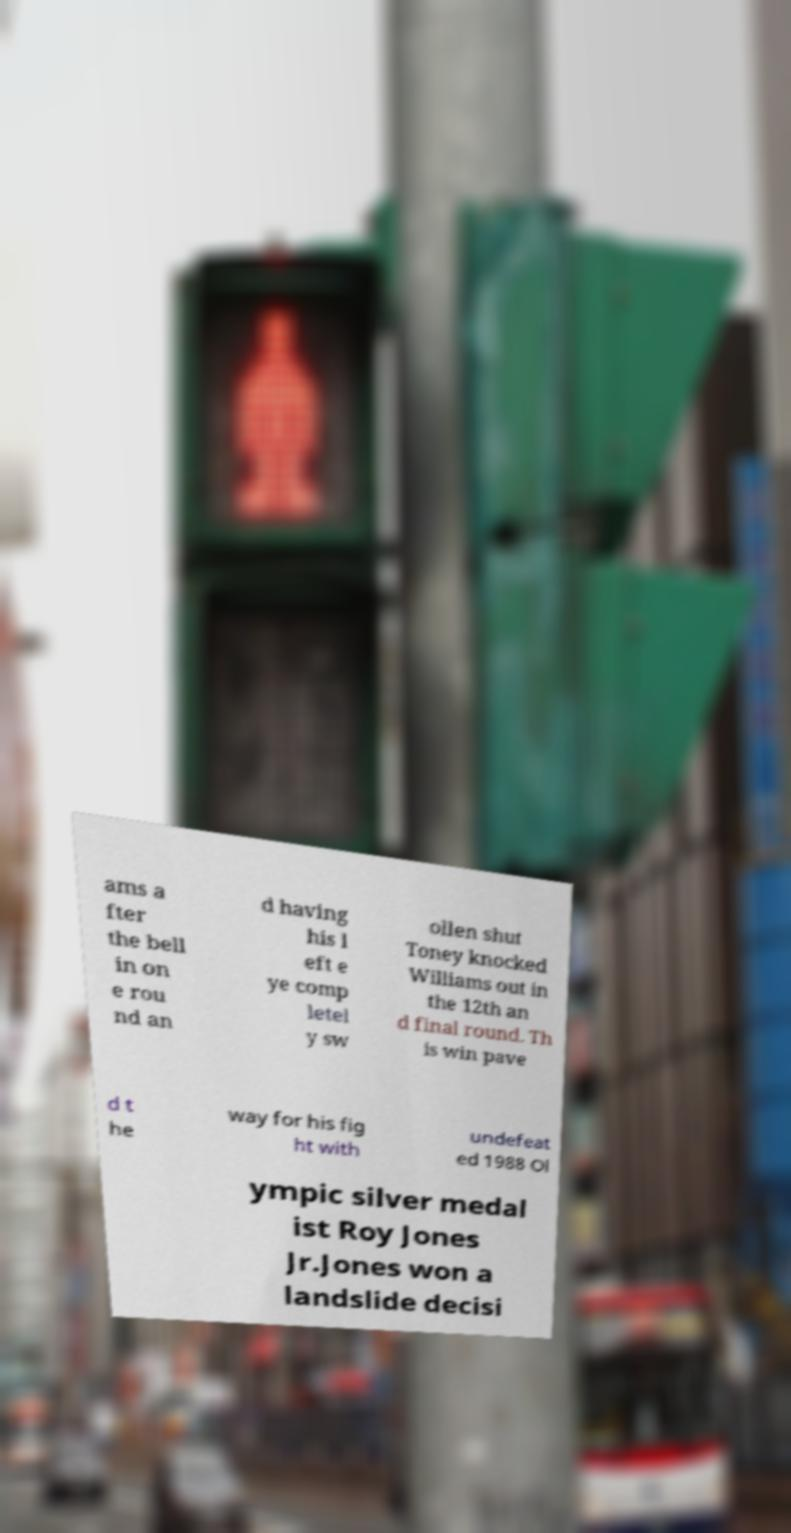Can you accurately transcribe the text from the provided image for me? ams a fter the bell in on e rou nd an d having his l eft e ye comp letel y sw ollen shut Toney knocked Williams out in the 12th an d final round. Th is win pave d t he way for his fig ht with undefeat ed 1988 Ol ympic silver medal ist Roy Jones Jr.Jones won a landslide decisi 